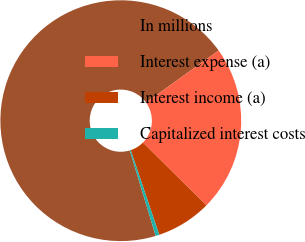<chart> <loc_0><loc_0><loc_500><loc_500><pie_chart><fcel>In millions<fcel>Interest expense (a)<fcel>Interest income (a)<fcel>Capitalized interest costs<nl><fcel>69.78%<fcel>22.32%<fcel>7.42%<fcel>0.49%<nl></chart> 